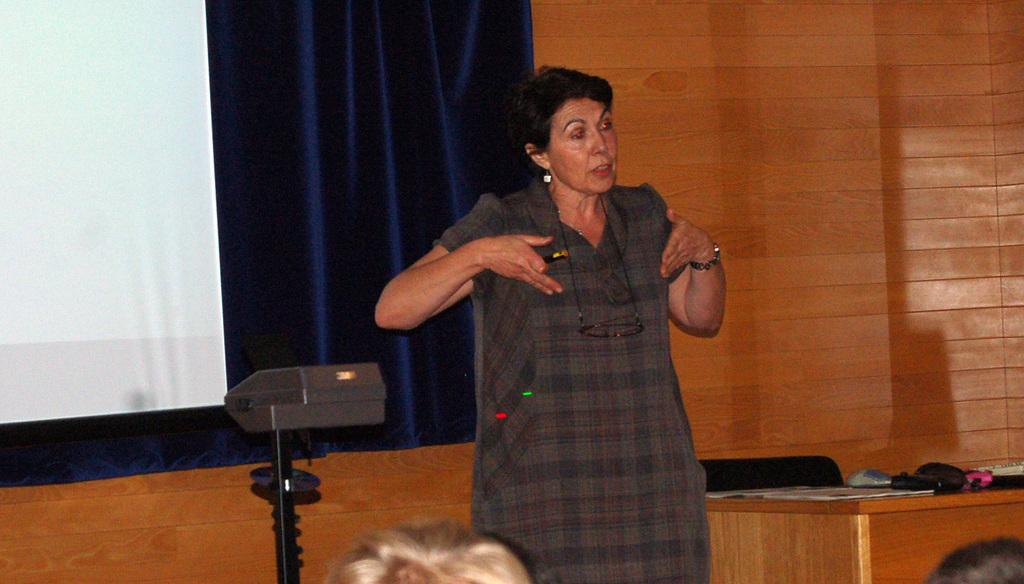Who is the main subject in the image? There is a woman in the image. Where is the woman positioned in the image? The woman is standing in the middle of the image. What is the woman doing in the image? The woman is talking. What can be seen behind the woman in the image? There is a curtain behind the woman. What type of star can be seen in the image? There is no star visible in the image. What song is the woman singing in the image? The image does not provide any information about the woman singing a song. 